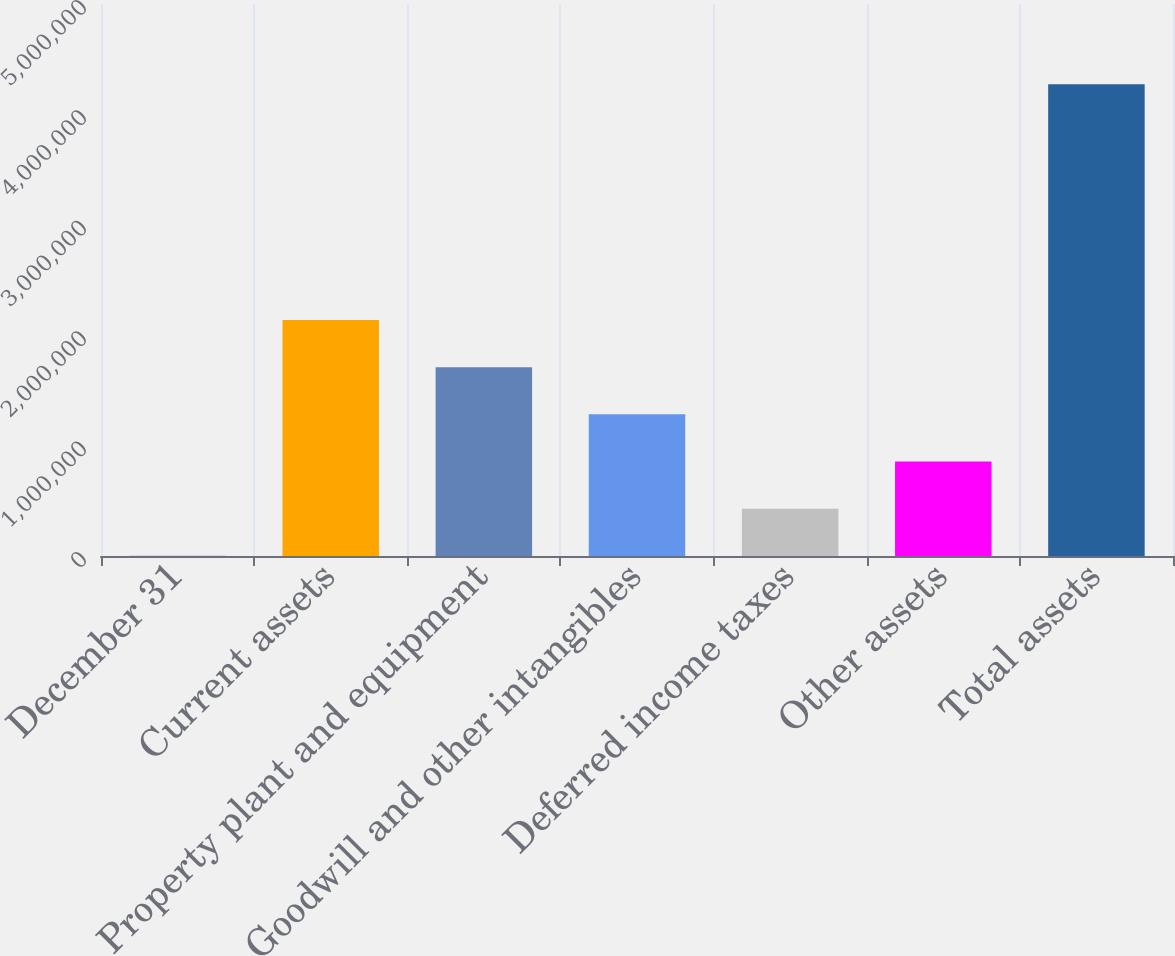<chart> <loc_0><loc_0><loc_500><loc_500><bar_chart><fcel>December 31<fcel>Current assets<fcel>Property plant and equipment<fcel>Goodwill and other intangibles<fcel>Deferred income taxes<fcel>Other assets<fcel>Total assets<nl><fcel>2010<fcel>2.13737e+06<fcel>1.7103e+06<fcel>1.28323e+06<fcel>429082<fcel>856154<fcel>4.27273e+06<nl></chart> 